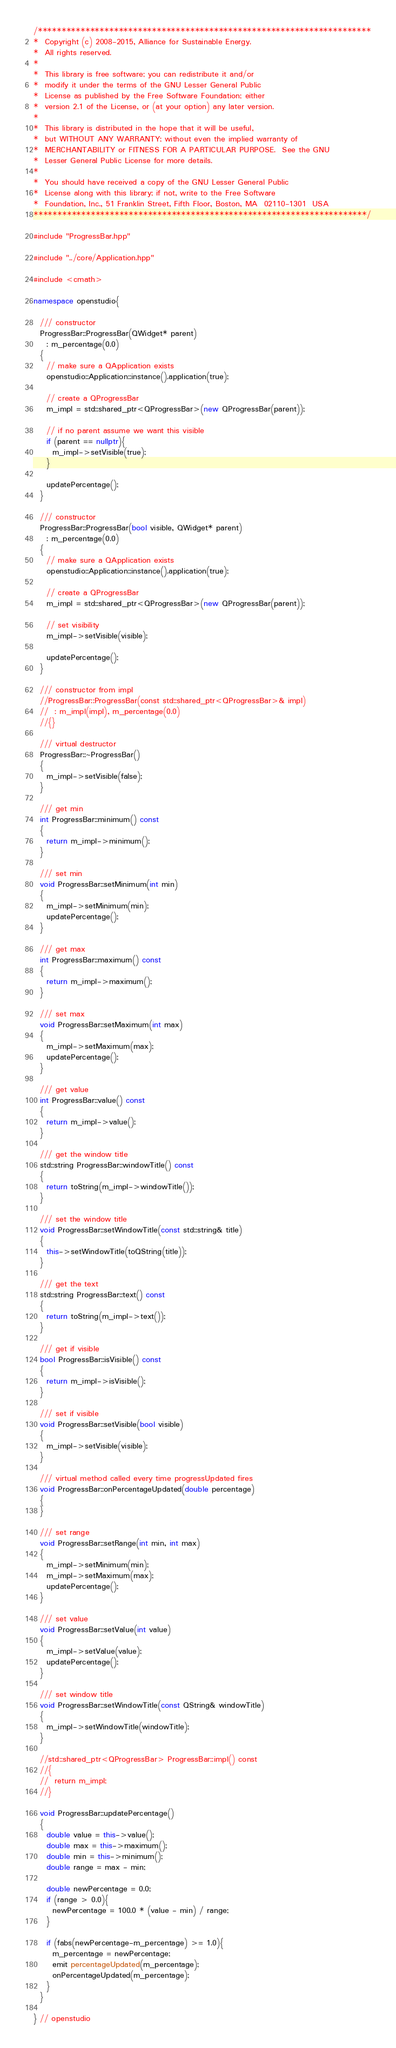<code> <loc_0><loc_0><loc_500><loc_500><_C++_>/**********************************************************************
*  Copyright (c) 2008-2015, Alliance for Sustainable Energy.  
*  All rights reserved.
*  
*  This library is free software; you can redistribute it and/or
*  modify it under the terms of the GNU Lesser General Public
*  License as published by the Free Software Foundation; either
*  version 2.1 of the License, or (at your option) any later version.
*  
*  This library is distributed in the hope that it will be useful,
*  but WITHOUT ANY WARRANTY; without even the implied warranty of
*  MERCHANTABILITY or FITNESS FOR A PARTICULAR PURPOSE.  See the GNU
*  Lesser General Public License for more details.
*  
*  You should have received a copy of the GNU Lesser General Public
*  License along with this library; if not, write to the Free Software
*  Foundation, Inc., 51 Franklin Street, Fifth Floor, Boston, MA  02110-1301  USA
**********************************************************************/

#include "ProgressBar.hpp"

#include "../core/Application.hpp"

#include <cmath>

namespace openstudio{

  /// constructor
  ProgressBar::ProgressBar(QWidget* parent)
    : m_percentage(0.0)
  {
    // make sure a QApplication exists
    openstudio::Application::instance().application(true);

    // create a QProgressBar
    m_impl = std::shared_ptr<QProgressBar>(new QProgressBar(parent));

    // if no parent assume we want this visible
    if (parent == nullptr){
      m_impl->setVisible(true);
    }

    updatePercentage();
  }

  /// constructor
  ProgressBar::ProgressBar(bool visible, QWidget* parent)
    : m_percentage(0.0)
  {
    // make sure a QApplication exists
    openstudio::Application::instance().application(true);

    // create a QProgressBar
    m_impl = std::shared_ptr<QProgressBar>(new QProgressBar(parent));
    
    // set visibility
    m_impl->setVisible(visible);

    updatePercentage();
  }

  /// constructor from impl
  //ProgressBar::ProgressBar(const std::shared_ptr<QProgressBar>& impl)
  //  : m_impl(impl), m_percentage(0.0)
  //{}

  /// virtual destructor
  ProgressBar::~ProgressBar()
  {
    m_impl->setVisible(false);
  }

  /// get min
  int ProgressBar::minimum() const
  {
    return m_impl->minimum();
  }

  /// set min
  void ProgressBar::setMinimum(int min)
  {
    m_impl->setMinimum(min);
    updatePercentage();
  }

  /// get max
  int ProgressBar::maximum() const
  {
    return m_impl->maximum();
  }

  /// set max
  void ProgressBar::setMaximum(int max)
  {
    m_impl->setMaximum(max);
    updatePercentage();
  }

  /// get value
  int ProgressBar::value() const
  {
    return m_impl->value();
  }

  /// get the window title
  std::string ProgressBar::windowTitle() const
  {
    return toString(m_impl->windowTitle());
  }

  /// set the window title
  void ProgressBar::setWindowTitle(const std::string& title)
  {
    this->setWindowTitle(toQString(title));
  }

  /// get the text
  std::string ProgressBar::text() const
  {
    return toString(m_impl->text());
  }

  /// get if visible
  bool ProgressBar::isVisible() const
  {
    return m_impl->isVisible();
  }

  /// set if visible
  void ProgressBar::setVisible(bool visible)
  {
    m_impl->setVisible(visible);
  }

  /// virtual method called every time progressUpdated fires
  void ProgressBar::onPercentageUpdated(double percentage)
  {
  }

  /// set range
  void ProgressBar::setRange(int min, int max)
  {
    m_impl->setMinimum(min);
    m_impl->setMaximum(max);
    updatePercentage();
  }

  /// set value
  void ProgressBar::setValue(int value)
  {
    m_impl->setValue(value);
    updatePercentage();
  }

  /// set window title
  void ProgressBar::setWindowTitle(const QString& windowTitle)
  {
    m_impl->setWindowTitle(windowTitle);
  }

  //std::shared_ptr<QProgressBar> ProgressBar::impl() const
  //{
  //  return m_impl;
  //}

  void ProgressBar::updatePercentage()
  {
    double value = this->value();
    double max = this->maximum();
    double min = this->minimum();
    double range = max - min;

    double newPercentage = 0.0;
    if (range > 0.0){
      newPercentage = 100.0 * (value - min) / range;
    }

    if (fabs(newPercentage-m_percentage) >= 1.0){
      m_percentage = newPercentage;
      emit percentageUpdated(m_percentage);
      onPercentageUpdated(m_percentage);
    }
  }

} // openstudio
</code> 